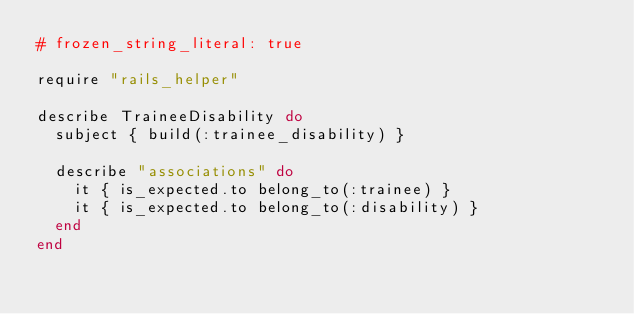<code> <loc_0><loc_0><loc_500><loc_500><_Ruby_># frozen_string_literal: true

require "rails_helper"

describe TraineeDisability do
  subject { build(:trainee_disability) }

  describe "associations" do
    it { is_expected.to belong_to(:trainee) }
    it { is_expected.to belong_to(:disability) }
  end
end
</code> 